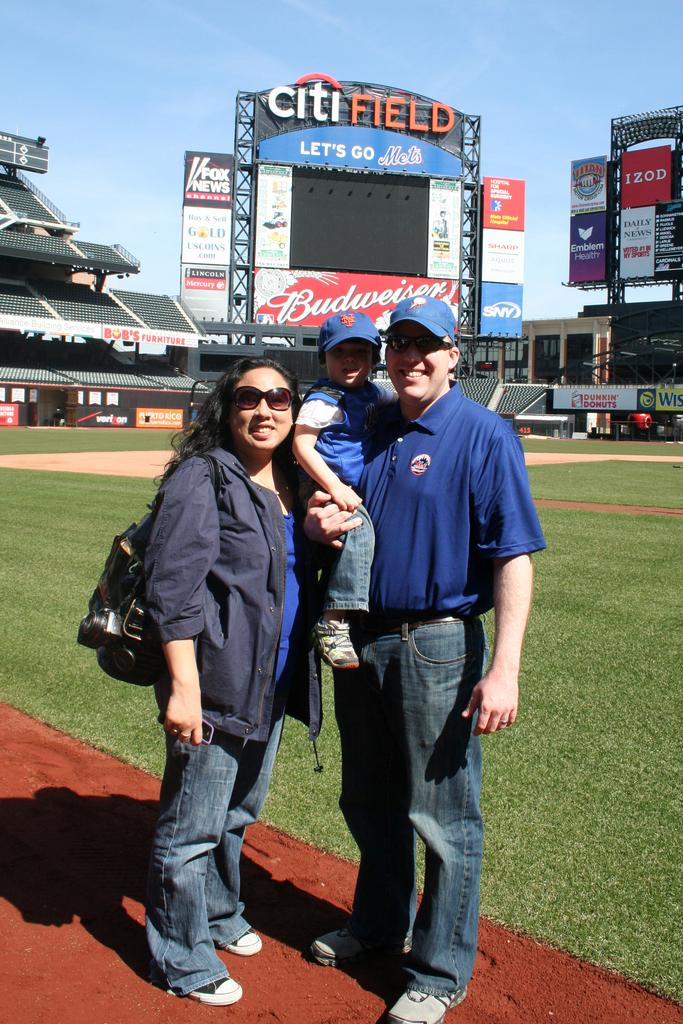<image>
Relay a brief, clear account of the picture shown. People are standing on a baseball field with a sign that says citi FIELD behind them. 